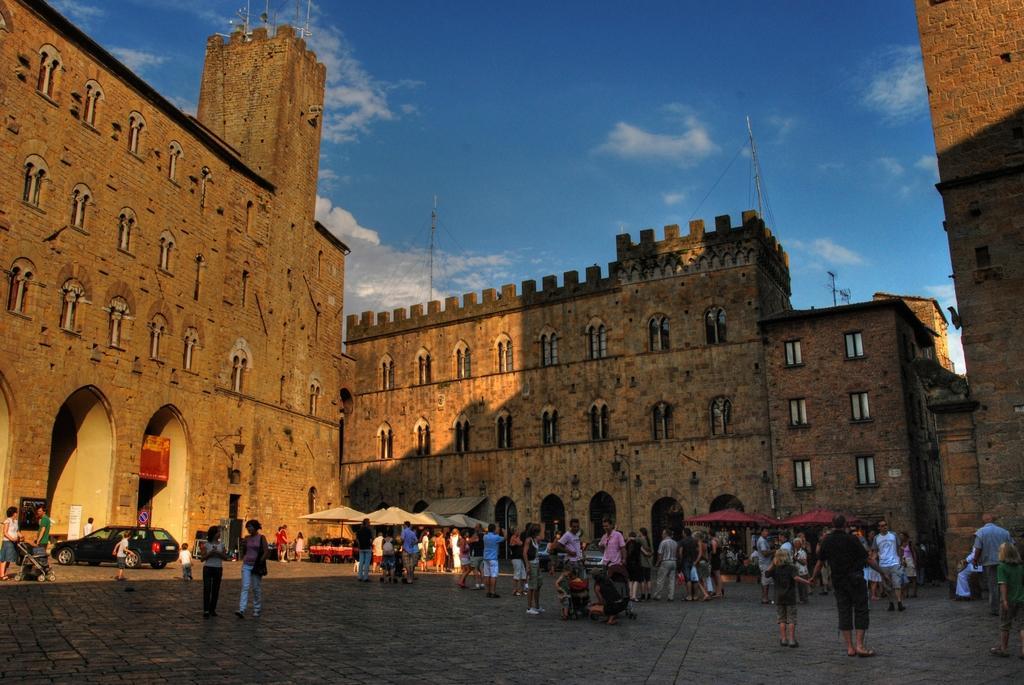Can you describe this image briefly? At the bottom of the image we can see parasols, motor vehicles, baby prams and people standing on the ground. In the background we can see buildings, windows, poles, towers, clouds and sky. 